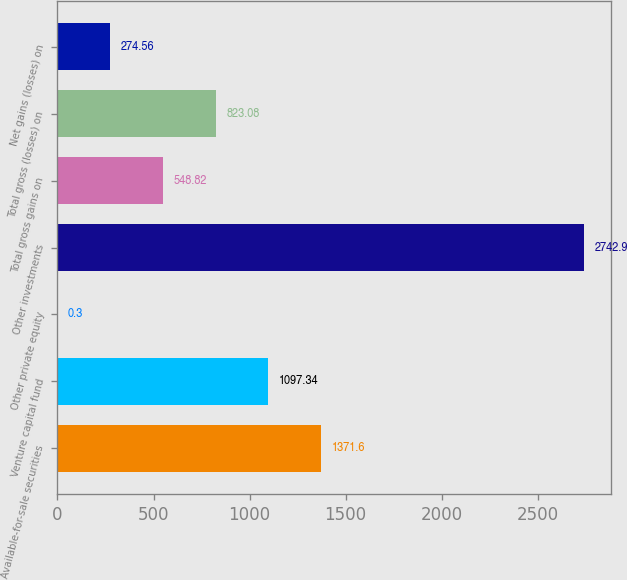<chart> <loc_0><loc_0><loc_500><loc_500><bar_chart><fcel>Available-for-sale securities<fcel>Venture capital fund<fcel>Other private equity<fcel>Other investments<fcel>Total gross gains on<fcel>Total gross (losses) on<fcel>Net gains (losses) on<nl><fcel>1371.6<fcel>1097.34<fcel>0.3<fcel>2742.9<fcel>548.82<fcel>823.08<fcel>274.56<nl></chart> 